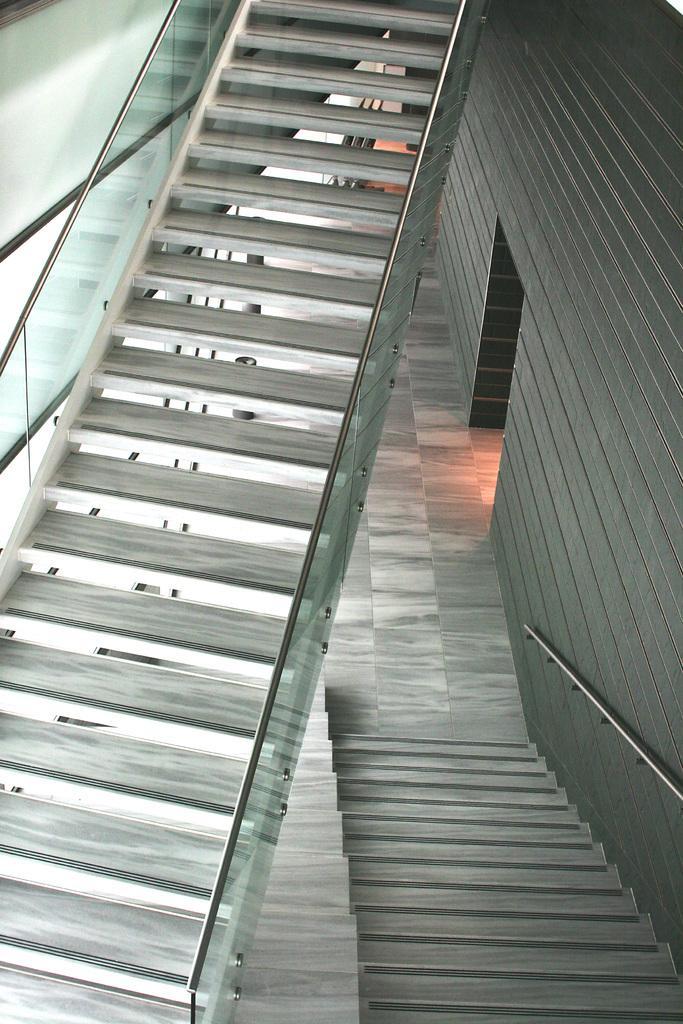Can you describe this image briefly? In this picture, we see staircases. On the right side of the picture, we see a building in brown color. On the left side of the picture, we see glass windows. 